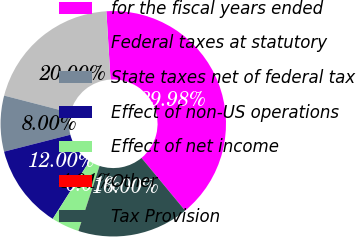<chart> <loc_0><loc_0><loc_500><loc_500><pie_chart><fcel>for the fiscal years ended<fcel>Federal taxes at statutory<fcel>State taxes net of federal tax<fcel>Effect of non-US operations<fcel>Effect of net income<fcel>Other<fcel>Tax Provision<nl><fcel>39.98%<fcel>20.0%<fcel>8.0%<fcel>12.0%<fcel>4.01%<fcel>0.01%<fcel>16.0%<nl></chart> 